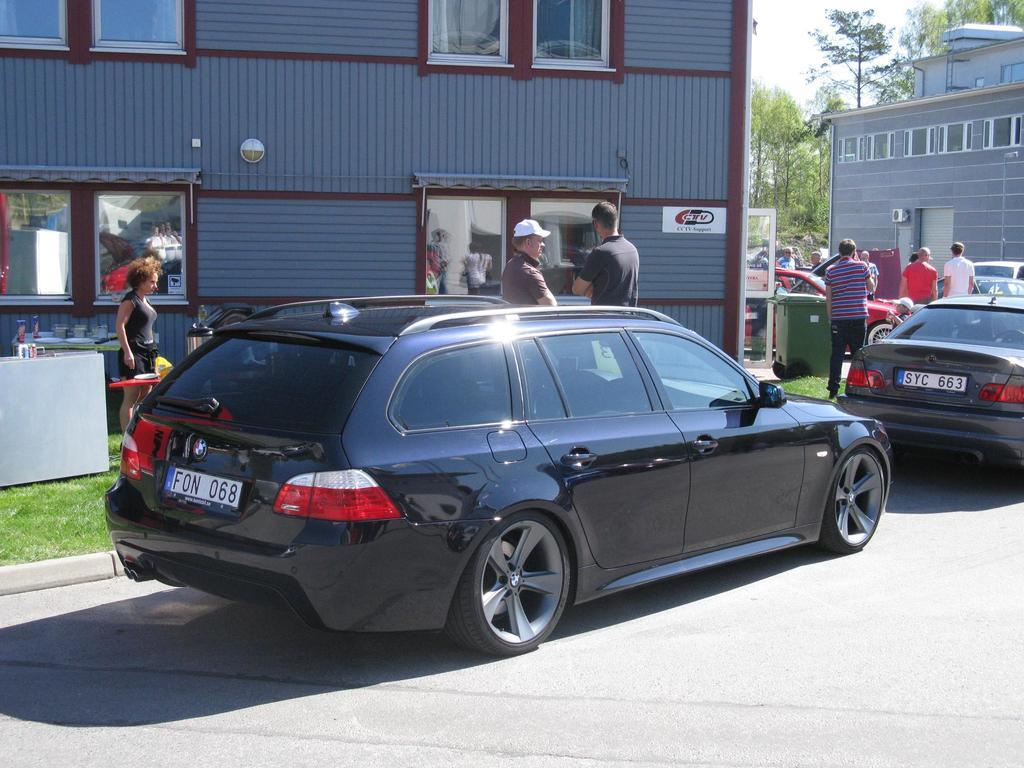Provide a one-sentence caption for the provided image. A dark blue hatchback with license plate number F0N 068 parked by a curb. 